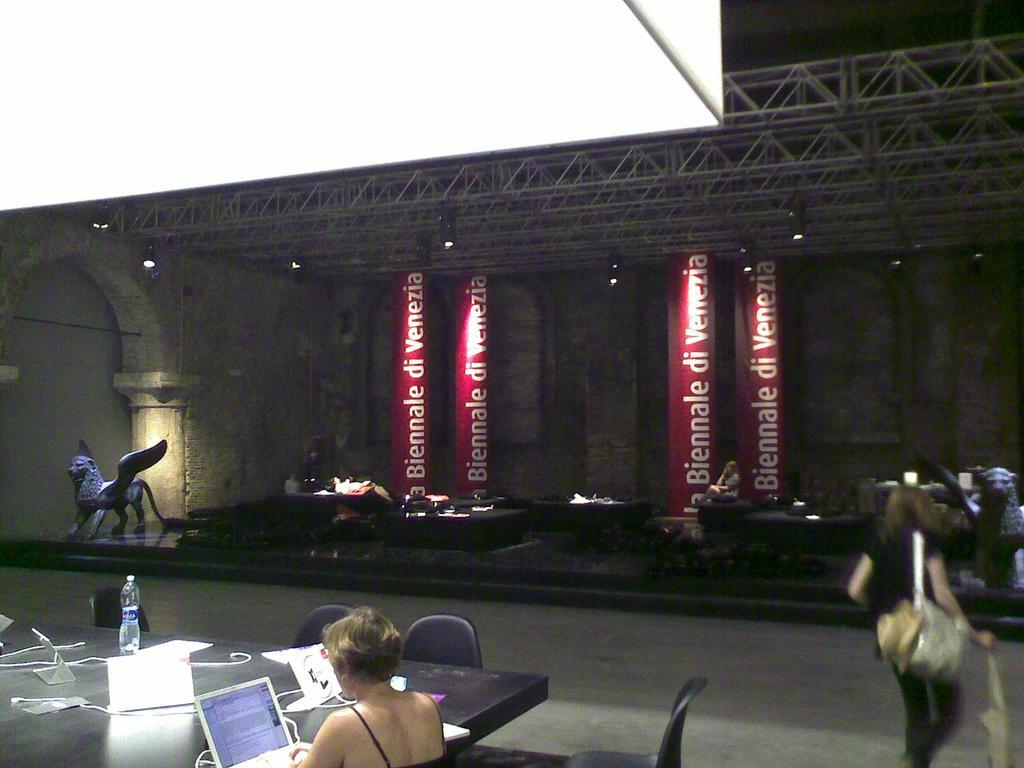What type of structure is visible in the image? There is a building in the image. What are the people in the image doing? The people in the image are sitting on chairs. What is on the table in the image? There are laptops and other objects placed on the table. What type of jam is being served on the table in the image? There is no jam present in the image; the table contains laptops and other objects. How many cats can be seen interacting with the laptops on the table? There are no cats present in the image; the table contains laptops and other objects. 